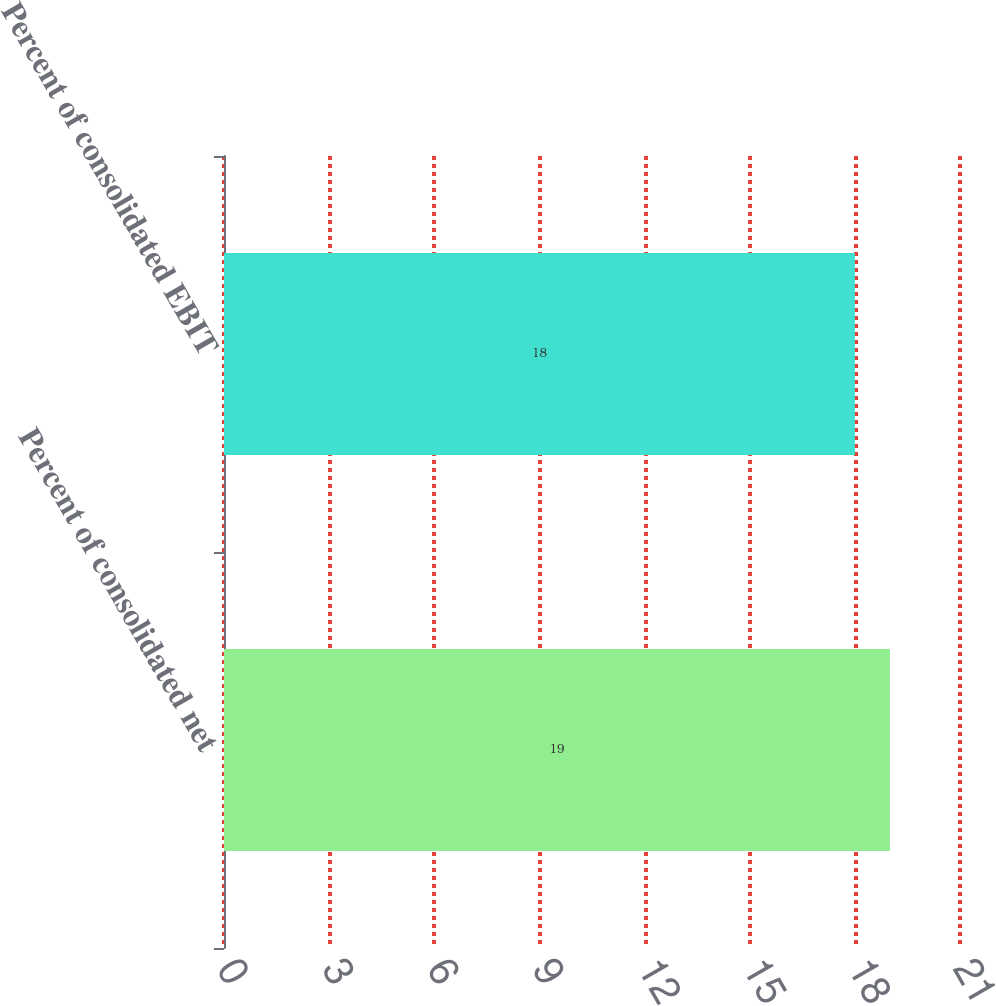<chart> <loc_0><loc_0><loc_500><loc_500><bar_chart><fcel>Percent of consolidated net<fcel>Percent of consolidated EBIT<nl><fcel>19<fcel>18<nl></chart> 